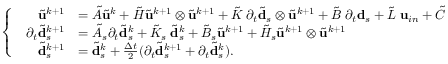Convert formula to latex. <formula><loc_0><loc_0><loc_500><loc_500>\left \{ \begin{array} { l l } { \begin{array} { r l } { \tilde { u } ^ { k + 1 } } & { = \tilde { A } \tilde { u } ^ { k } + \tilde { H } \tilde { u } ^ { k + 1 } \otimes \tilde { u } ^ { k + 1 } + \tilde { K } \, \partial _ { t } \tilde { d } _ { s } \otimes \tilde { u } ^ { k + 1 } + \tilde { B } \, \partial _ { t } d _ { s } + \tilde { L } \, u _ { i n } + \tilde { C } } \\ { \partial _ { t } \tilde { d } _ { s } ^ { k + 1 } } & { = \tilde { A } _ { s } \partial _ { t } \tilde { d } _ { s } ^ { k } + \tilde { K } _ { s } \, \tilde { d } _ { s } ^ { k } + \tilde { B } _ { s } \tilde { u } ^ { k + 1 } + \tilde { H } _ { s } \tilde { u } ^ { k + 1 } \otimes \tilde { u } ^ { k + 1 } } \\ { \tilde { d } _ { s } ^ { k + 1 } } & { = \tilde { d } _ { s } ^ { k } + \frac { \Delta t } { 2 } ( \partial _ { t } \tilde { d } _ { s } ^ { k + 1 } + \partial _ { t } \tilde { d } _ { s } ^ { k } ) . } \end{array} } \end{array}</formula> 